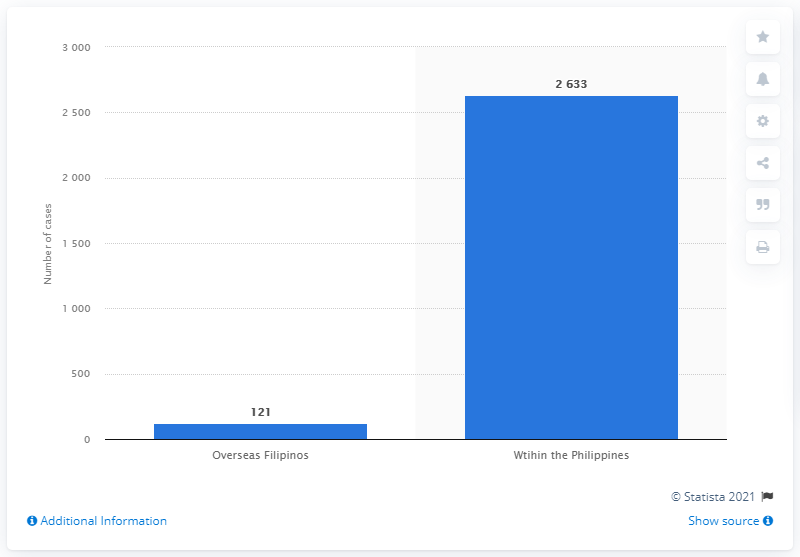Point out several critical features in this image. As of February 17, 2023, it is reported that 121 Filipinos have been infected with coronavirus COVID-19. As of February 22, 2023, the Philippines has reported 121 cases of COVID-19, with 7 deaths. 